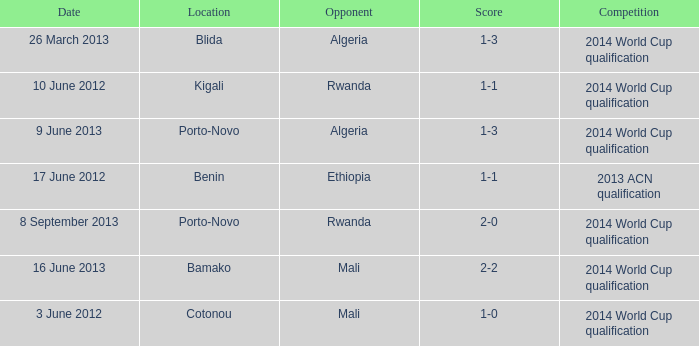What rivalry occurs in bamako? 2014 World Cup qualification. Could you parse the entire table? {'header': ['Date', 'Location', 'Opponent', 'Score', 'Competition'], 'rows': [['26 March 2013', 'Blida', 'Algeria', '1-3', '2014 World Cup qualification'], ['10 June 2012', 'Kigali', 'Rwanda', '1-1', '2014 World Cup qualification'], ['9 June 2013', 'Porto-Novo', 'Algeria', '1-3', '2014 World Cup qualification'], ['17 June 2012', 'Benin', 'Ethiopia', '1-1', '2013 ACN qualification'], ['8 September 2013', 'Porto-Novo', 'Rwanda', '2-0', '2014 World Cup qualification'], ['16 June 2013', 'Bamako', 'Mali', '2-2', '2014 World Cup qualification'], ['3 June 2012', 'Cotonou', 'Mali', '1-0', '2014 World Cup qualification']]} 